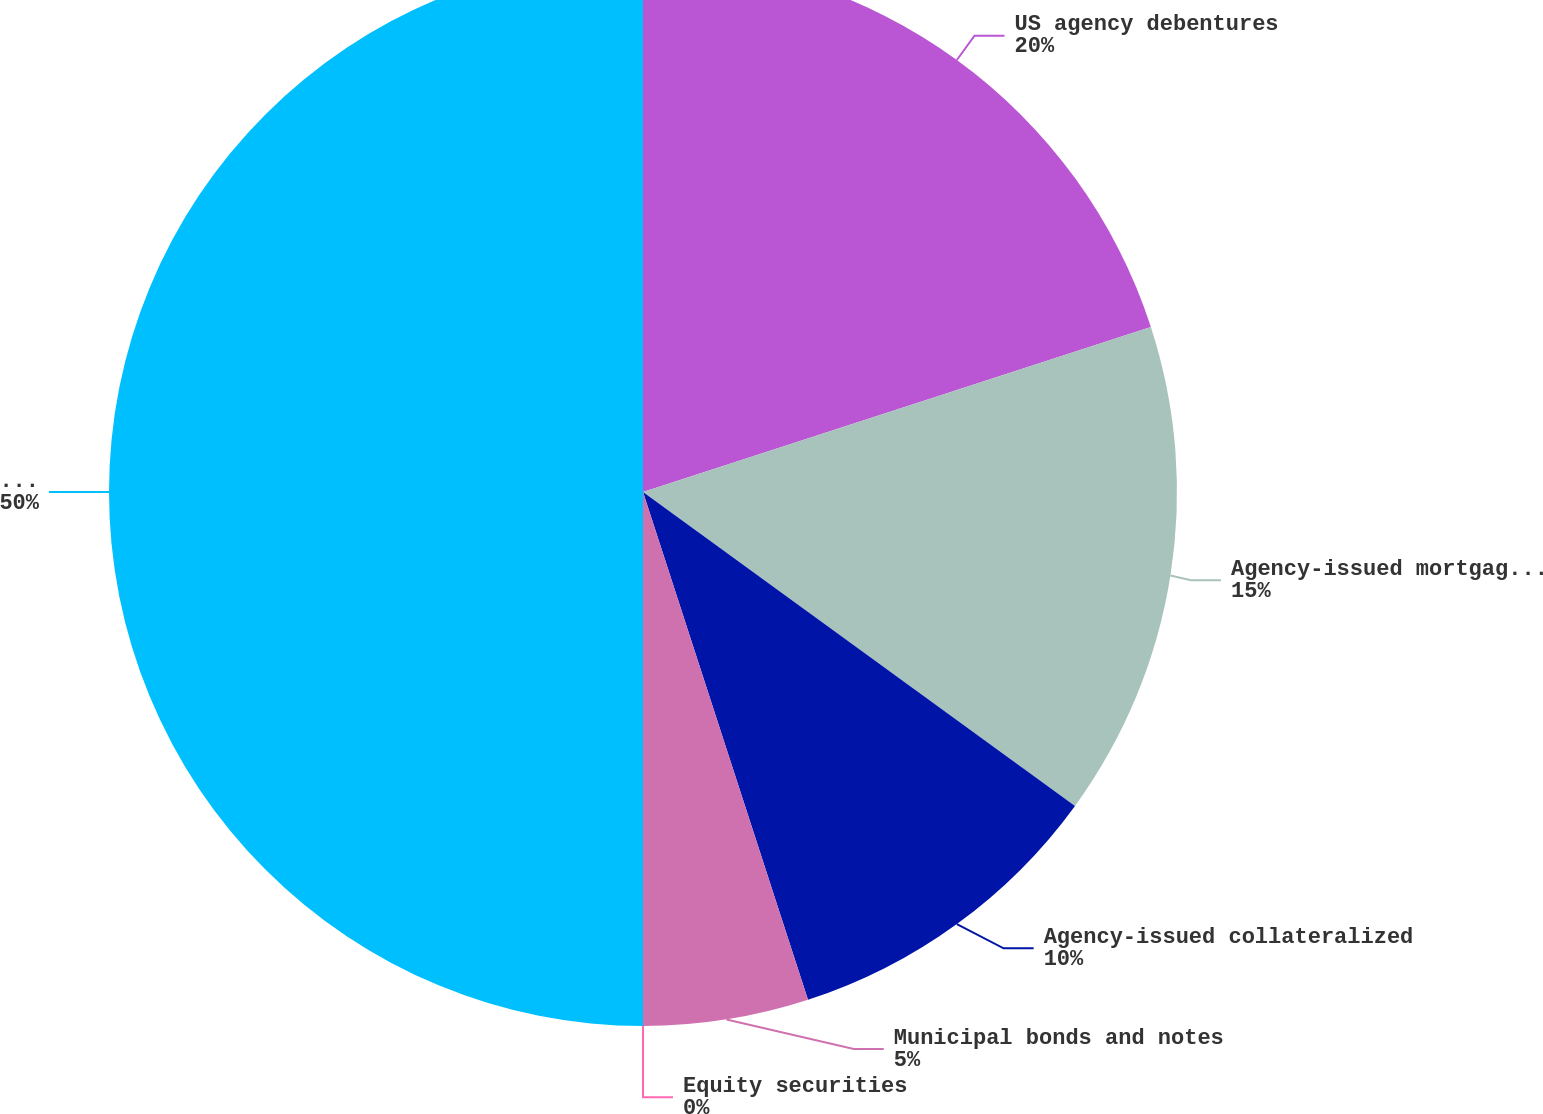Convert chart. <chart><loc_0><loc_0><loc_500><loc_500><pie_chart><fcel>US agency debentures<fcel>Agency-issued mortgage-backed<fcel>Agency-issued collateralized<fcel>Municipal bonds and notes<fcel>Equity securities<fcel>Total available-for-sale<nl><fcel>20.0%<fcel>15.0%<fcel>10.0%<fcel>5.0%<fcel>0.0%<fcel>50.0%<nl></chart> 